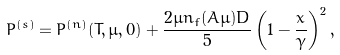<formula> <loc_0><loc_0><loc_500><loc_500>P ^ { ( s ) } = P ^ { ( n ) } ( T , \mu , 0 ) + \frac { 2 \mu n _ { f } ( A \mu ) D } { 5 } \left ( 1 - \frac { x } { \gamma } \right ) ^ { 2 } ,</formula> 